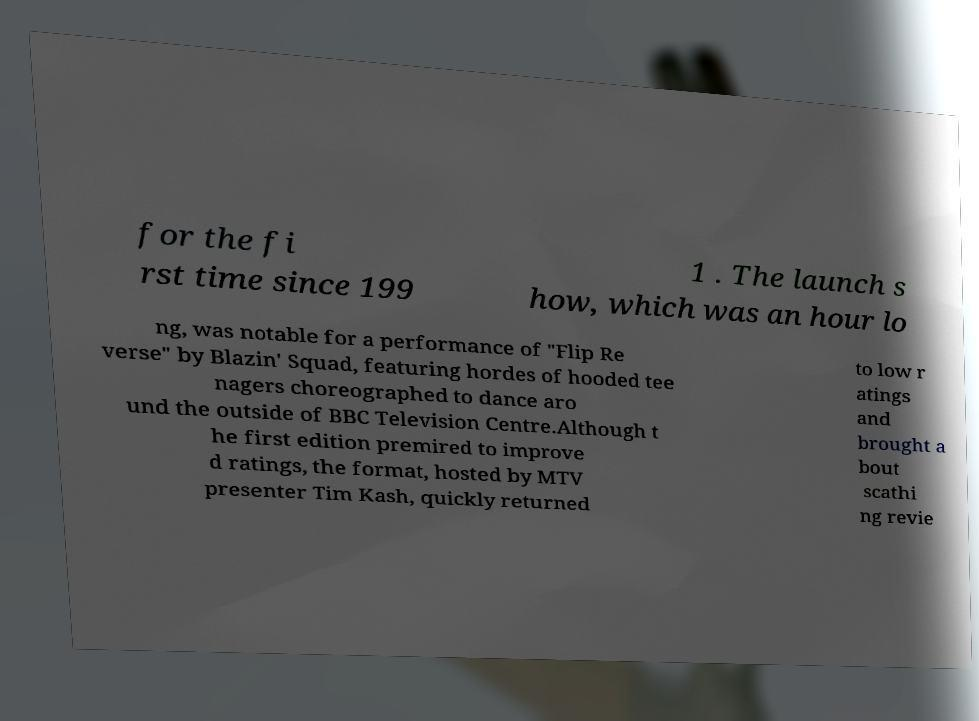Could you extract and type out the text from this image? for the fi rst time since 199 1 . The launch s how, which was an hour lo ng, was notable for a performance of "Flip Re verse" by Blazin' Squad, featuring hordes of hooded tee nagers choreographed to dance aro und the outside of BBC Television Centre.Although t he first edition premired to improve d ratings, the format, hosted by MTV presenter Tim Kash, quickly returned to low r atings and brought a bout scathi ng revie 